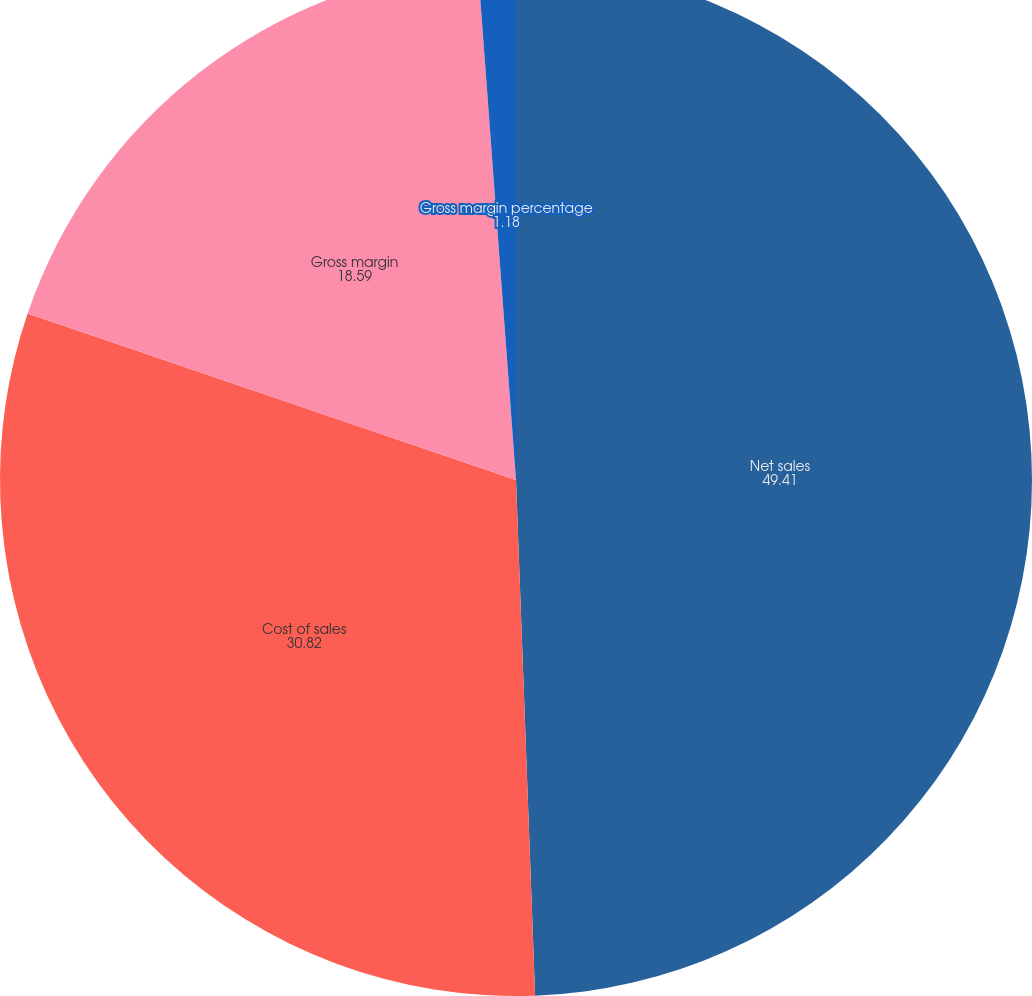<chart> <loc_0><loc_0><loc_500><loc_500><pie_chart><fcel>Net sales<fcel>Cost of sales<fcel>Gross margin<fcel>Gross margin percentage<nl><fcel>49.41%<fcel>30.82%<fcel>18.59%<fcel>1.18%<nl></chart> 